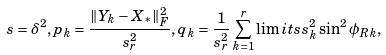<formula> <loc_0><loc_0><loc_500><loc_500>s = \delta ^ { 2 } , p _ { k } = \frac { \| Y _ { k } - X _ { * } \| ^ { 2 } _ { F } } { s _ { r } ^ { 2 } } , q _ { k } = \frac { 1 } { s _ { r } ^ { 2 } } \sum _ { k = 1 } ^ { r } \lim i t s s _ { k } ^ { 2 } \sin ^ { 2 } \phi _ { R k } ,</formula> 